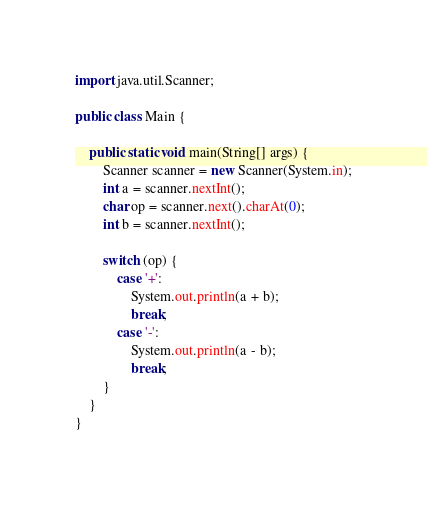Convert code to text. <code><loc_0><loc_0><loc_500><loc_500><_Java_>import java.util.Scanner;

public class Main {

    public static void main(String[] args) {
        Scanner scanner = new Scanner(System.in);
        int a = scanner.nextInt();
        char op = scanner.next().charAt(0);
        int b = scanner.nextInt();

        switch (op) {
            case '+':
                System.out.println(a + b);
                break;
            case '-':
                System.out.println(a - b);
                break;
        }
    }
}</code> 